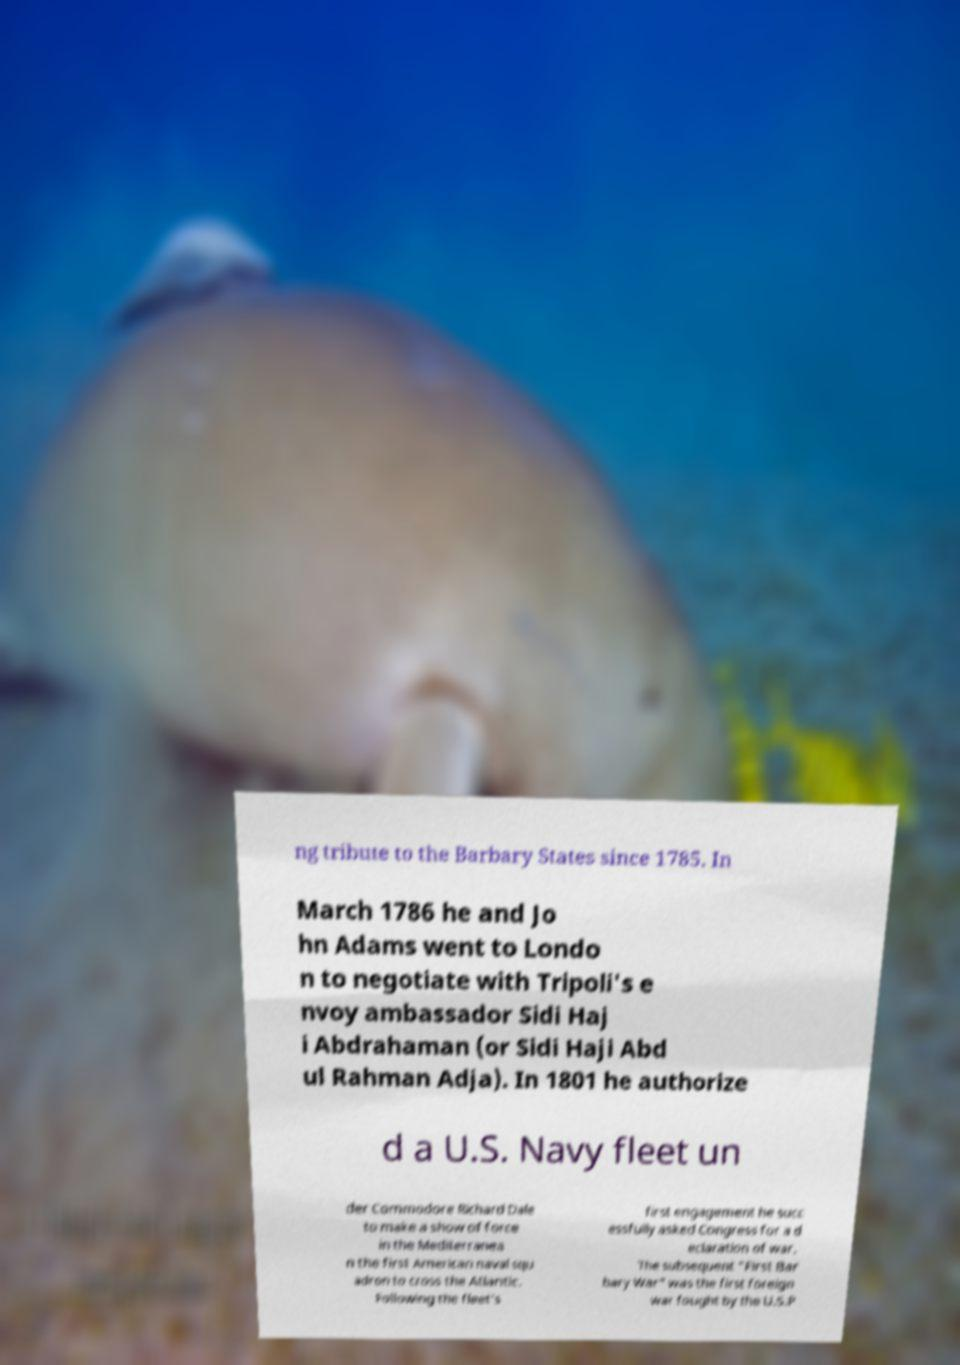I need the written content from this picture converted into text. Can you do that? ng tribute to the Barbary States since 1785. In March 1786 he and Jo hn Adams went to Londo n to negotiate with Tripoli's e nvoy ambassador Sidi Haj i Abdrahaman (or Sidi Haji Abd ul Rahman Adja). In 1801 he authorize d a U.S. Navy fleet un der Commodore Richard Dale to make a show of force in the Mediterranea n the first American naval squ adron to cross the Atlantic. Following the fleet's first engagement he succ essfully asked Congress for a d eclaration of war. The subsequent "First Bar bary War" was the first foreign war fought by the U.S.P 